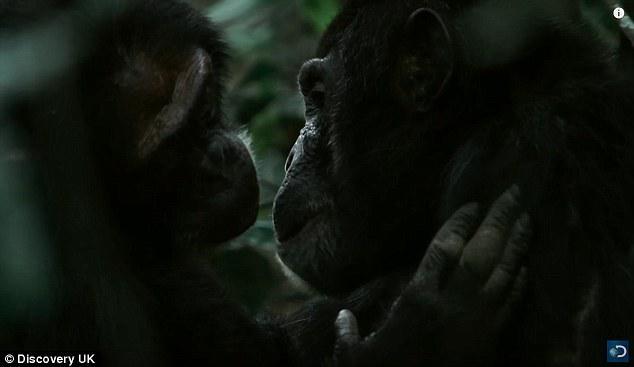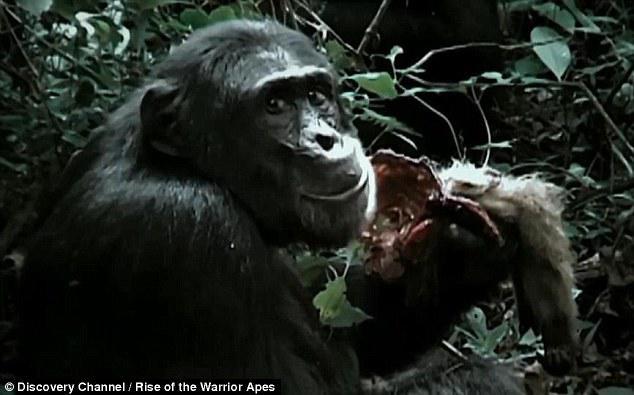The first image is the image on the left, the second image is the image on the right. Considering the images on both sides, is "Each image contains a single chimpanzee, and the chimps in the left and right images are gazing in the same general direction, but none look straight at the camera with a level gaze." valid? Answer yes or no. No. 